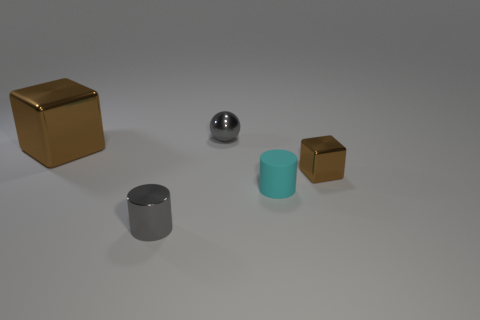What shape is the cyan rubber thing that is the same size as the gray cylinder? cylinder 